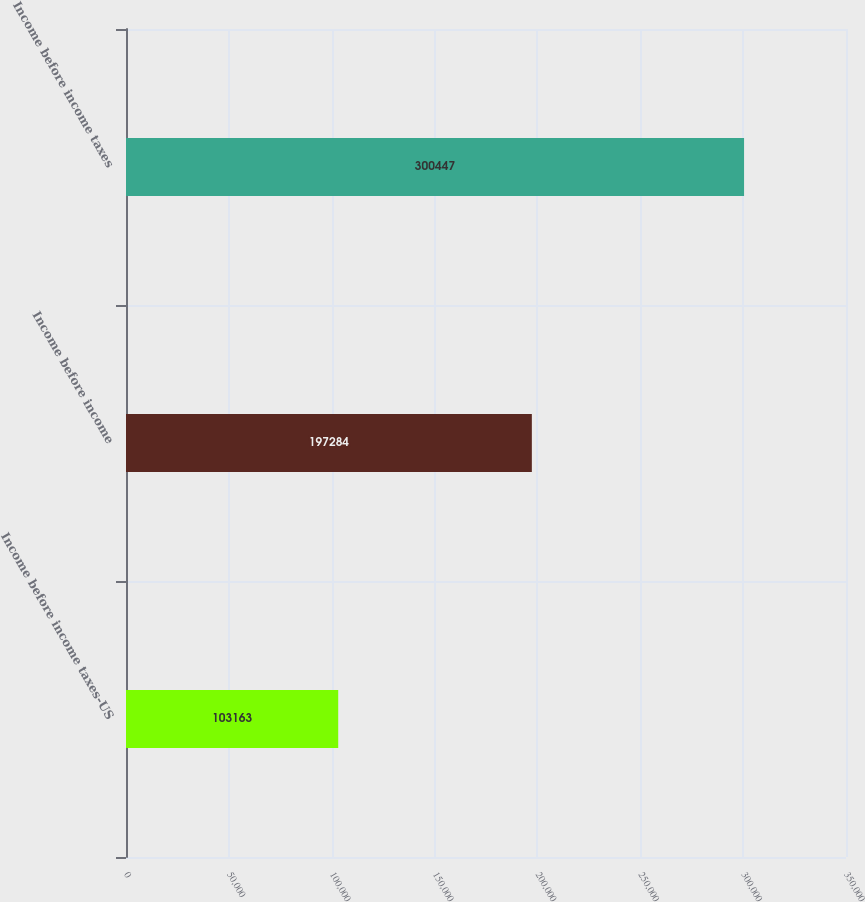Convert chart. <chart><loc_0><loc_0><loc_500><loc_500><bar_chart><fcel>Income before income taxes-US<fcel>Income before income<fcel>Income before income taxes<nl><fcel>103163<fcel>197284<fcel>300447<nl></chart> 